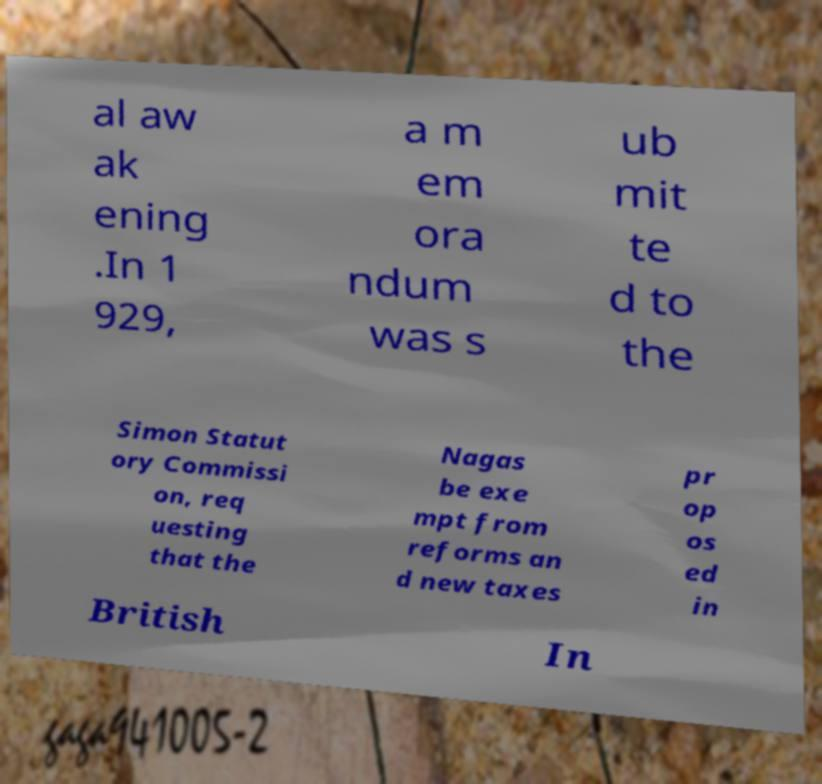For documentation purposes, I need the text within this image transcribed. Could you provide that? al aw ak ening .In 1 929, a m em ora ndum was s ub mit te d to the Simon Statut ory Commissi on, req uesting that the Nagas be exe mpt from reforms an d new taxes pr op os ed in British In 